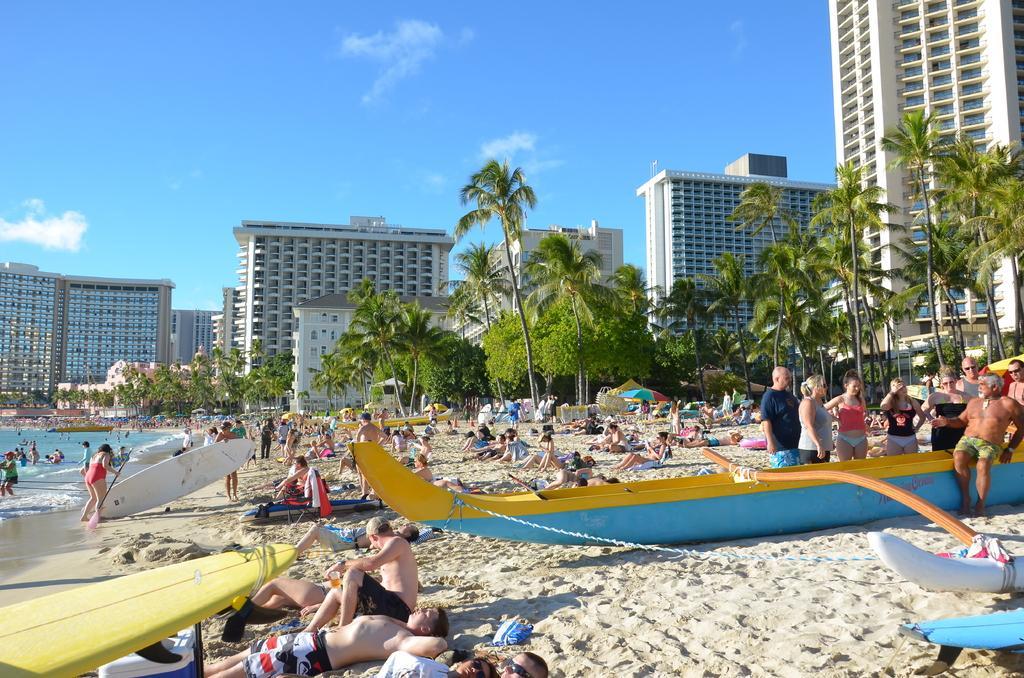Please provide a concise description of this image. In this image, we can see people, sand, boats, surf boards and few things. On the left side of the image, we can see people in the water. In the background, there are so many trees, buildings, walls, windows and the sky. 